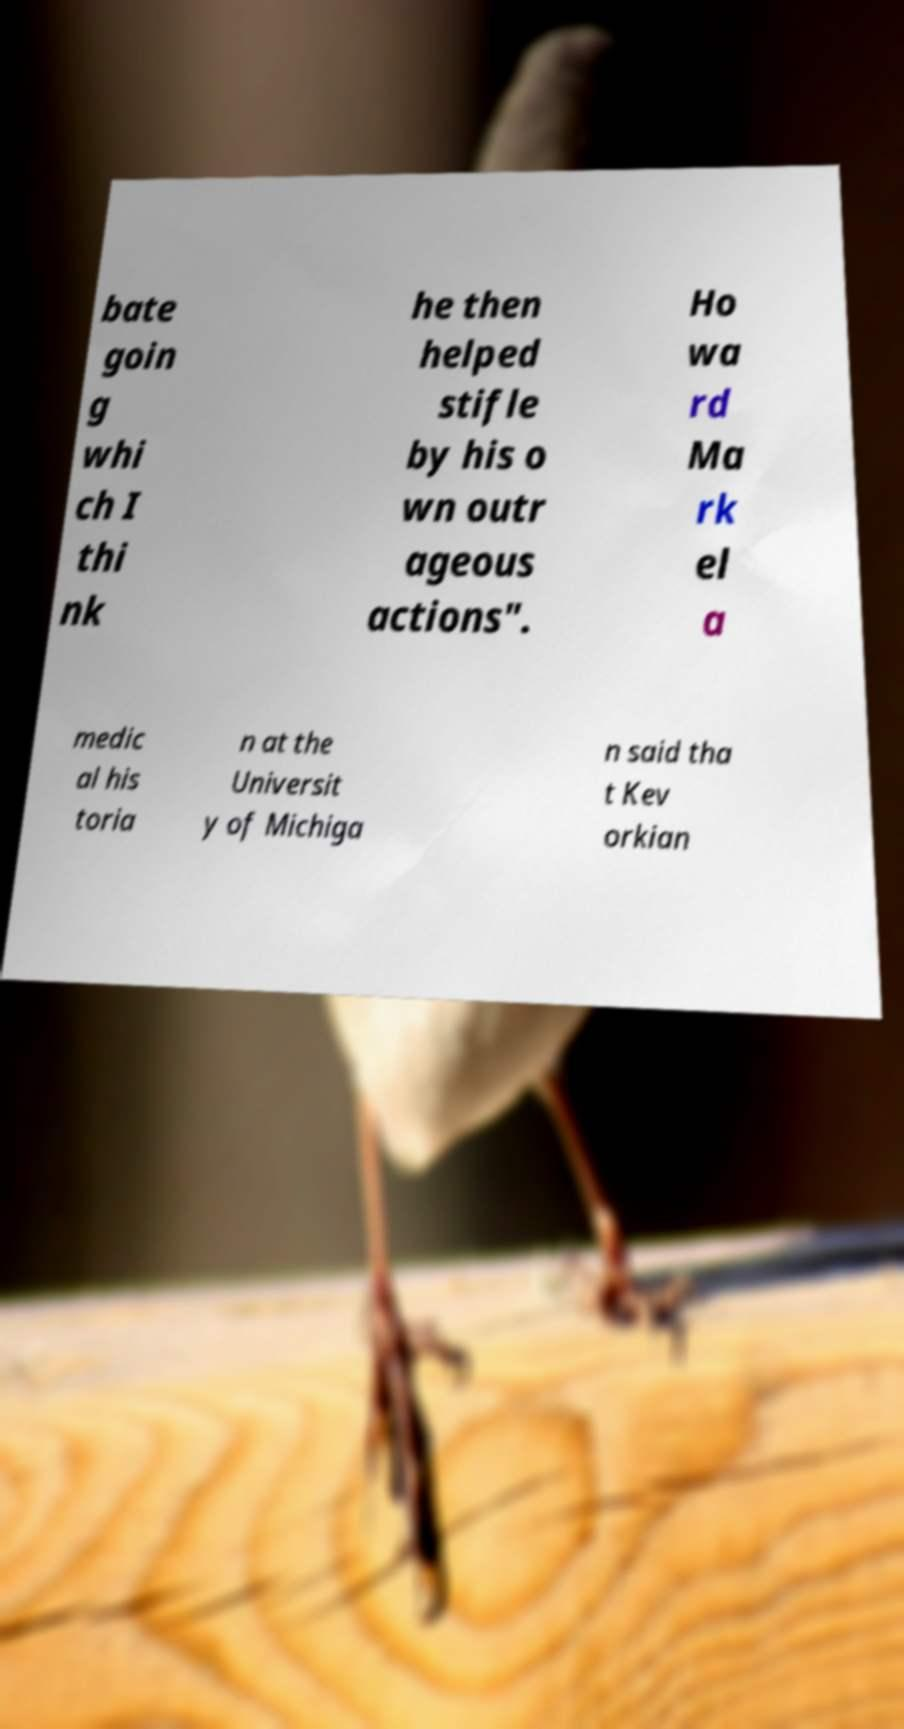What messages or text are displayed in this image? I need them in a readable, typed format. bate goin g whi ch I thi nk he then helped stifle by his o wn outr ageous actions". Ho wa rd Ma rk el a medic al his toria n at the Universit y of Michiga n said tha t Kev orkian 